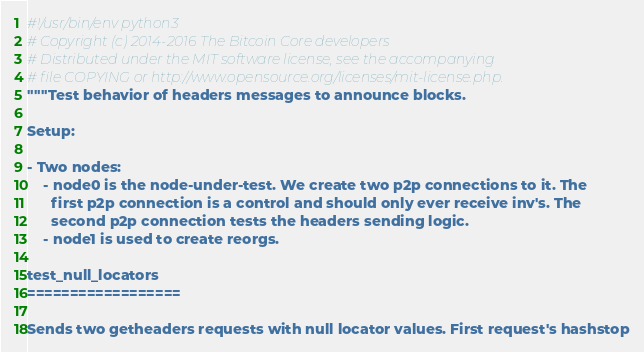<code> <loc_0><loc_0><loc_500><loc_500><_Python_>#!/usr/bin/env python3
# Copyright (c) 2014-2016 The Bitcoin Core developers
# Distributed under the MIT software license, see the accompanying
# file COPYING or http://www.opensource.org/licenses/mit-license.php.
"""Test behavior of headers messages to announce blocks.

Setup:

- Two nodes:
    - node0 is the node-under-test. We create two p2p connections to it. The
      first p2p connection is a control and should only ever receive inv's. The
      second p2p connection tests the headers sending logic.
    - node1 is used to create reorgs.

test_null_locators
==================

Sends two getheaders requests with null locator values. First request's hashstop</code> 